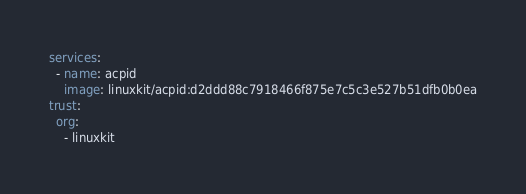<code> <loc_0><loc_0><loc_500><loc_500><_YAML_>services:
  - name: acpid
    image: linuxkit/acpid:d2ddd88c7918466f875e7c5c3e527b51dfb0b0ea
trust:
  org:
    - linuxkit
</code> 